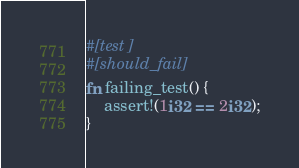<code> <loc_0><loc_0><loc_500><loc_500><_Rust_>#[test]
#[should_fail]
fn failing_test() {
    assert!(1i32 == 2i32);
}
</code> 